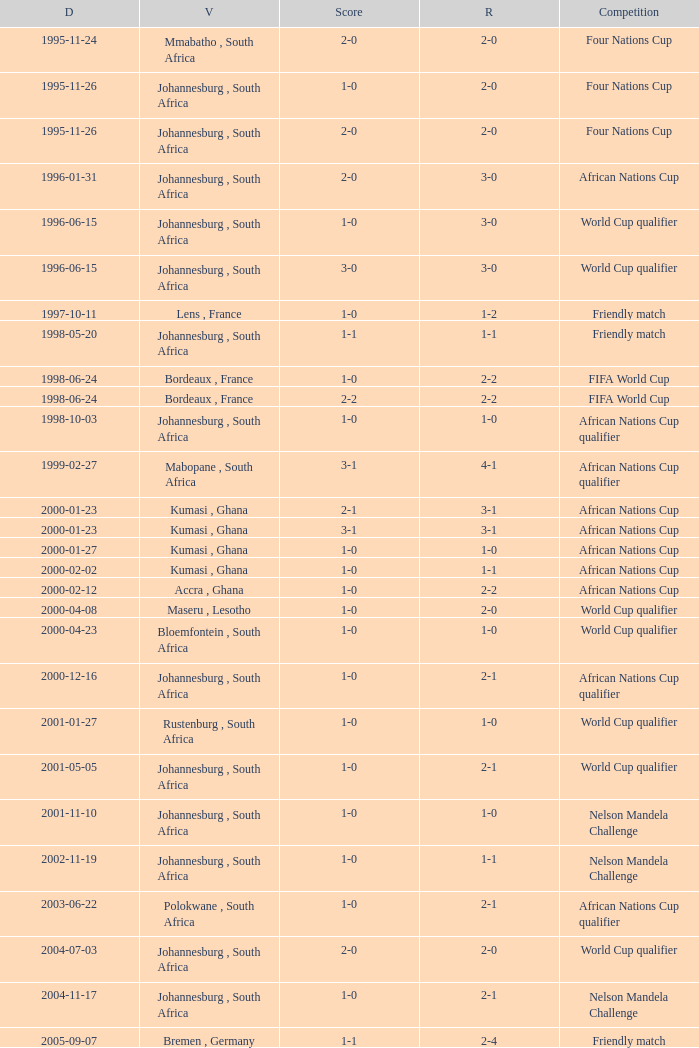What is the Venue of the Competition on 2001-05-05? Johannesburg , South Africa. 